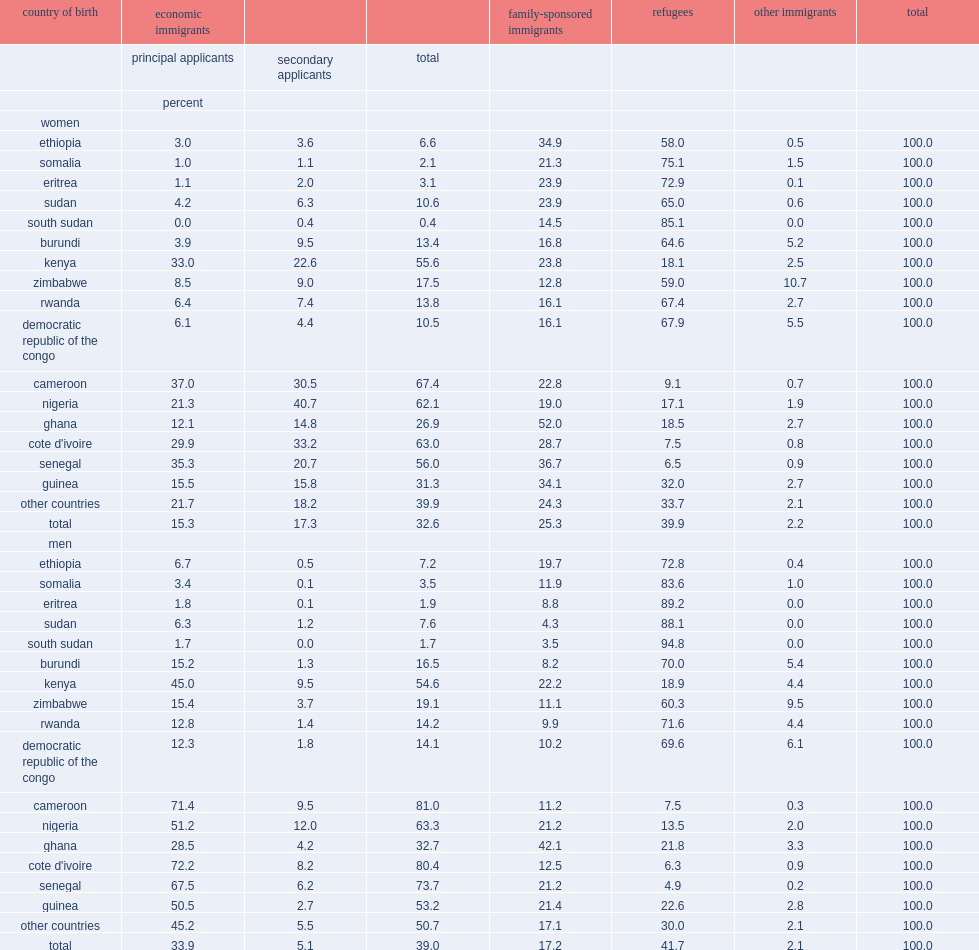List african countries of origin that have more than half of the male immigrants admitted as a principal applicant under the economic program. Cameroon cote d'ivoire senegal. 